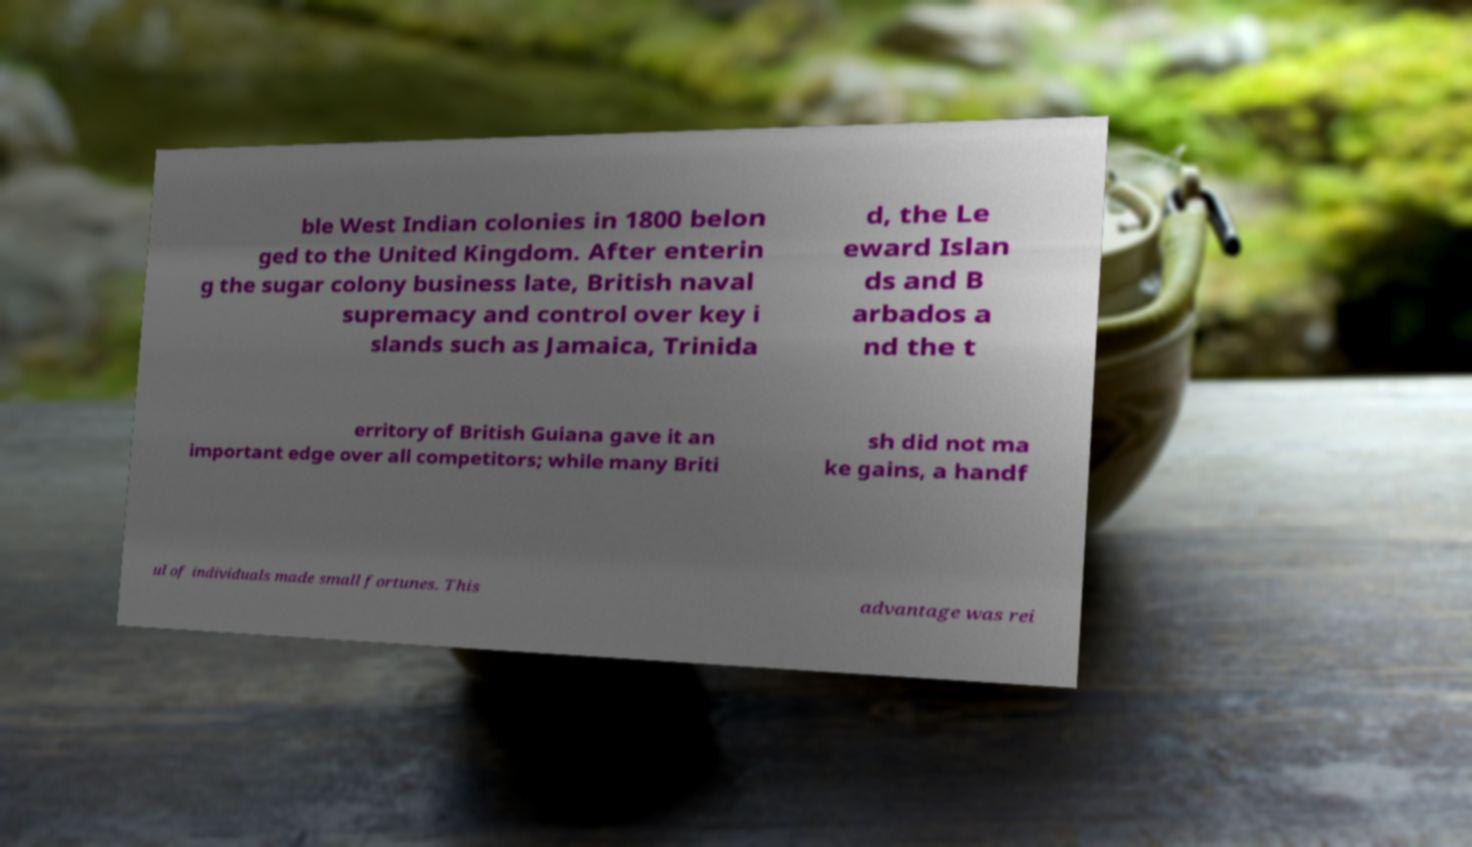Can you accurately transcribe the text from the provided image for me? ble West Indian colonies in 1800 belon ged to the United Kingdom. After enterin g the sugar colony business late, British naval supremacy and control over key i slands such as Jamaica, Trinida d, the Le eward Islan ds and B arbados a nd the t erritory of British Guiana gave it an important edge over all competitors; while many Briti sh did not ma ke gains, a handf ul of individuals made small fortunes. This advantage was rei 